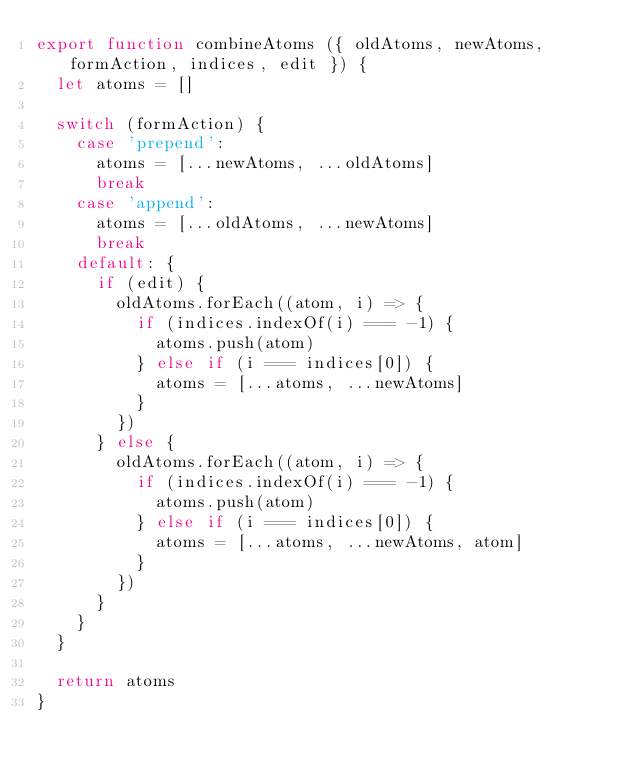<code> <loc_0><loc_0><loc_500><loc_500><_JavaScript_>export function combineAtoms ({ oldAtoms, newAtoms, formAction, indices, edit }) {
  let atoms = []

  switch (formAction) {
    case 'prepend':
      atoms = [...newAtoms, ...oldAtoms]
      break
    case 'append':
      atoms = [...oldAtoms, ...newAtoms]
      break
    default: {
      if (edit) {
        oldAtoms.forEach((atom, i) => {
          if (indices.indexOf(i) === -1) {
            atoms.push(atom)
          } else if (i === indices[0]) {
            atoms = [...atoms, ...newAtoms]
          }
        })
      } else {
        oldAtoms.forEach((atom, i) => {
          if (indices.indexOf(i) === -1) {
            atoms.push(atom)
          } else if (i === indices[0]) {
            atoms = [...atoms, ...newAtoms, atom]
          }
        })
      }
    }
  }

  return atoms
}
</code> 